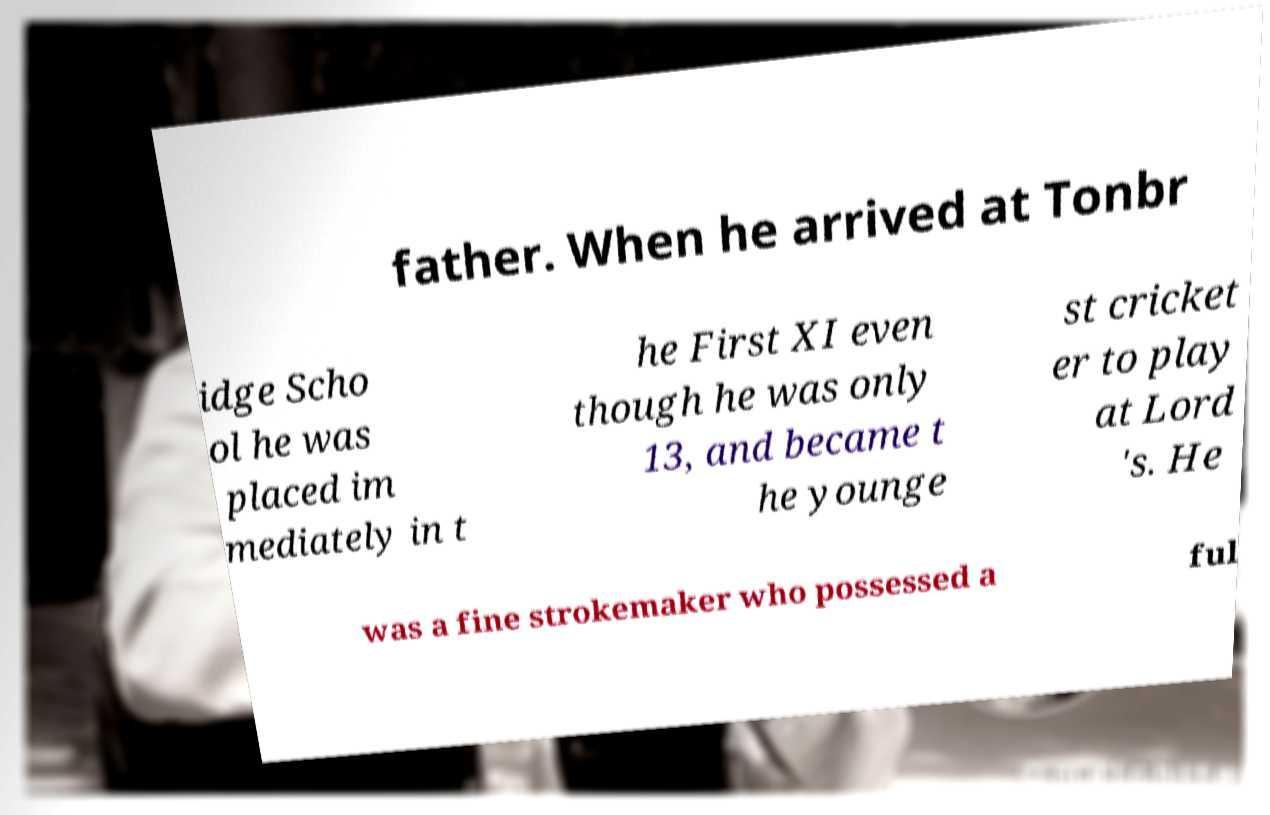Can you read and provide the text displayed in the image?This photo seems to have some interesting text. Can you extract and type it out for me? father. When he arrived at Tonbr idge Scho ol he was placed im mediately in t he First XI even though he was only 13, and became t he younge st cricket er to play at Lord 's. He was a fine strokemaker who possessed a ful 